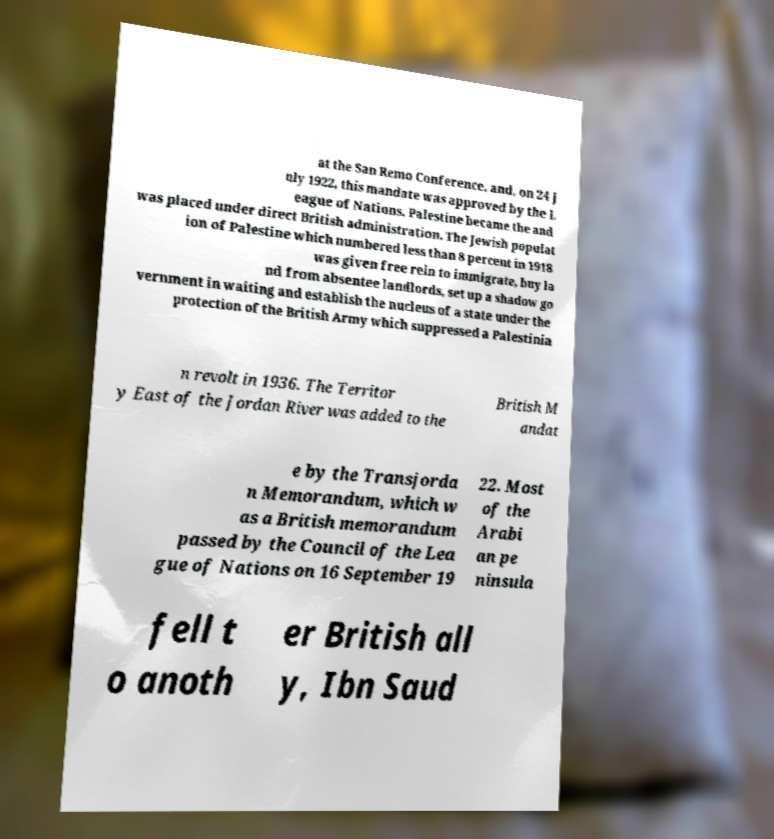Could you assist in decoding the text presented in this image and type it out clearly? at the San Remo Conference, and, on 24 J uly 1922, this mandate was approved by the L eague of Nations. Palestine became the and was placed under direct British administration. The Jewish populat ion of Palestine which numbered less than 8 percent in 1918 was given free rein to immigrate, buy la nd from absentee landlords, set up a shadow go vernment in waiting and establish the nucleus of a state under the protection of the British Army which suppressed a Palestinia n revolt in 1936. The Territor y East of the Jordan River was added to the British M andat e by the Transjorda n Memorandum, which w as a British memorandum passed by the Council of the Lea gue of Nations on 16 September 19 22. Most of the Arabi an pe ninsula fell t o anoth er British all y, Ibn Saud 